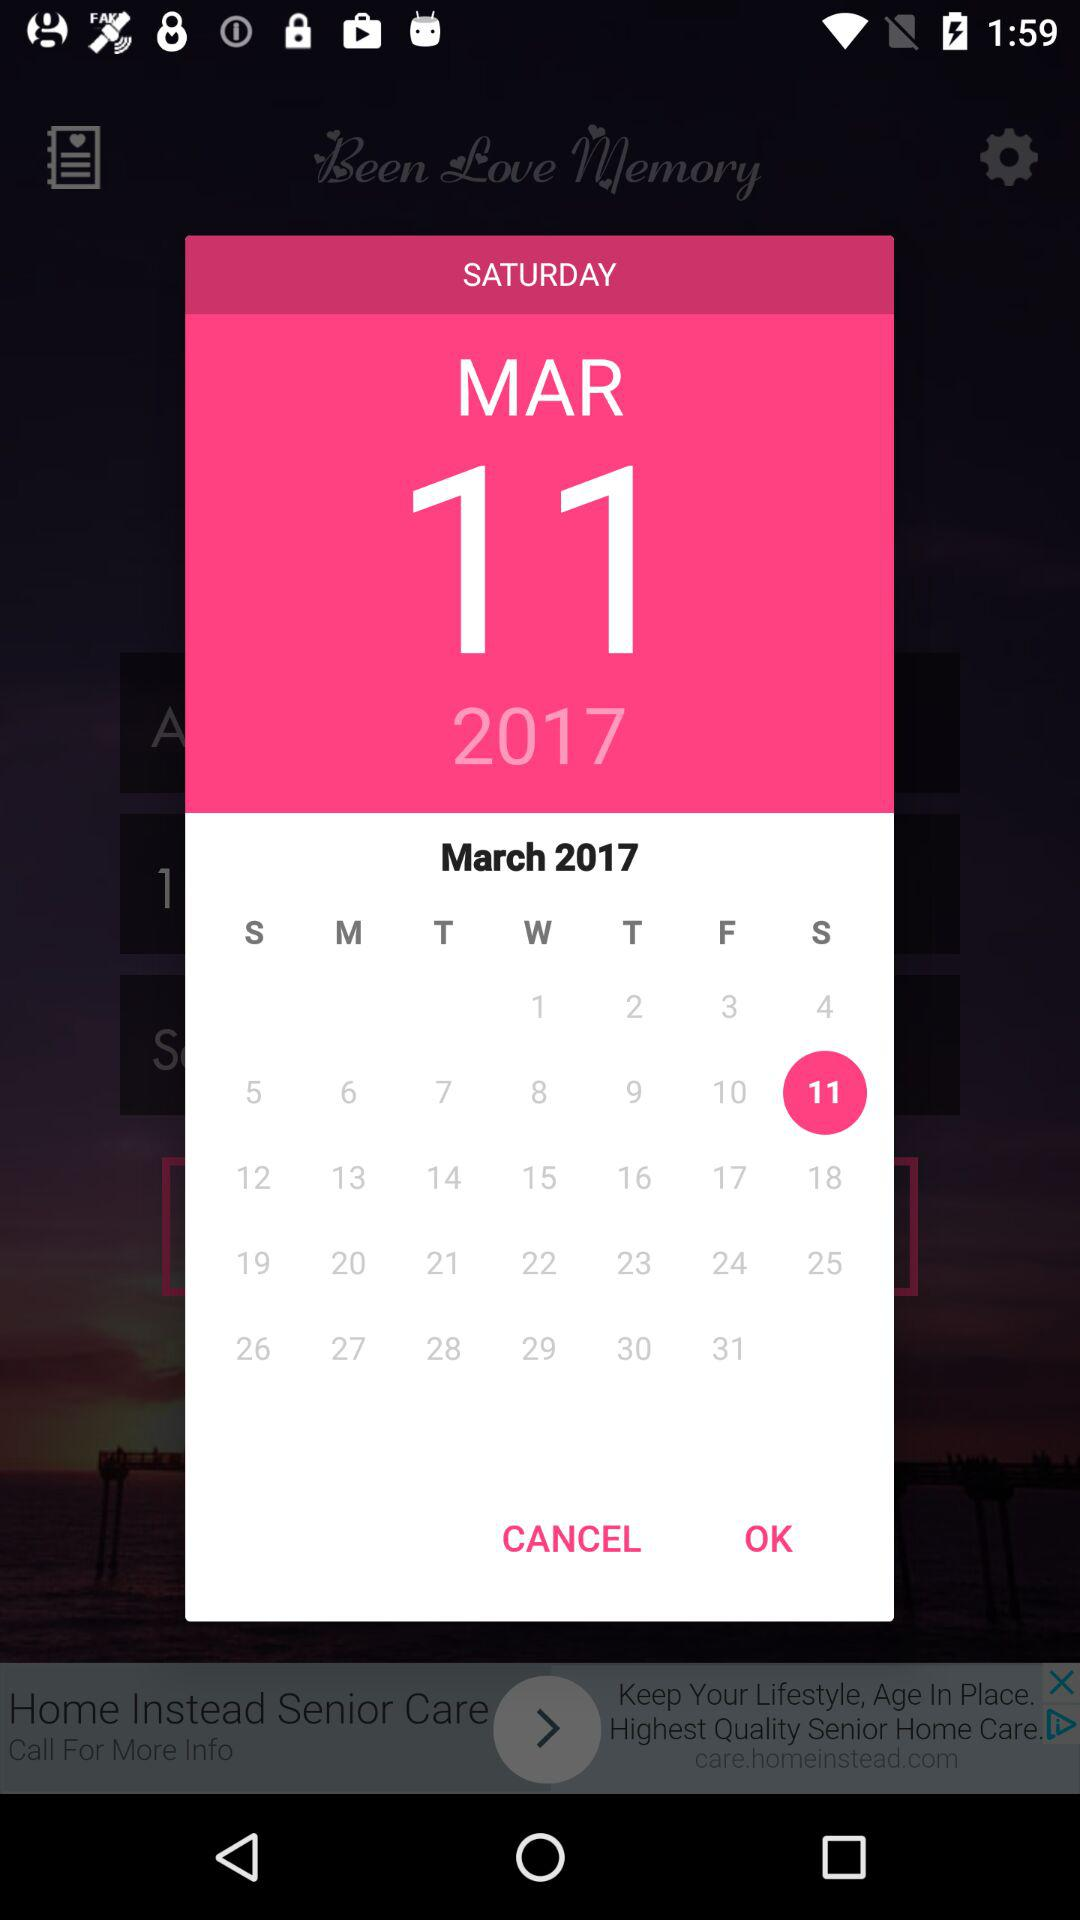What year is selected? The selected year is 2017. 